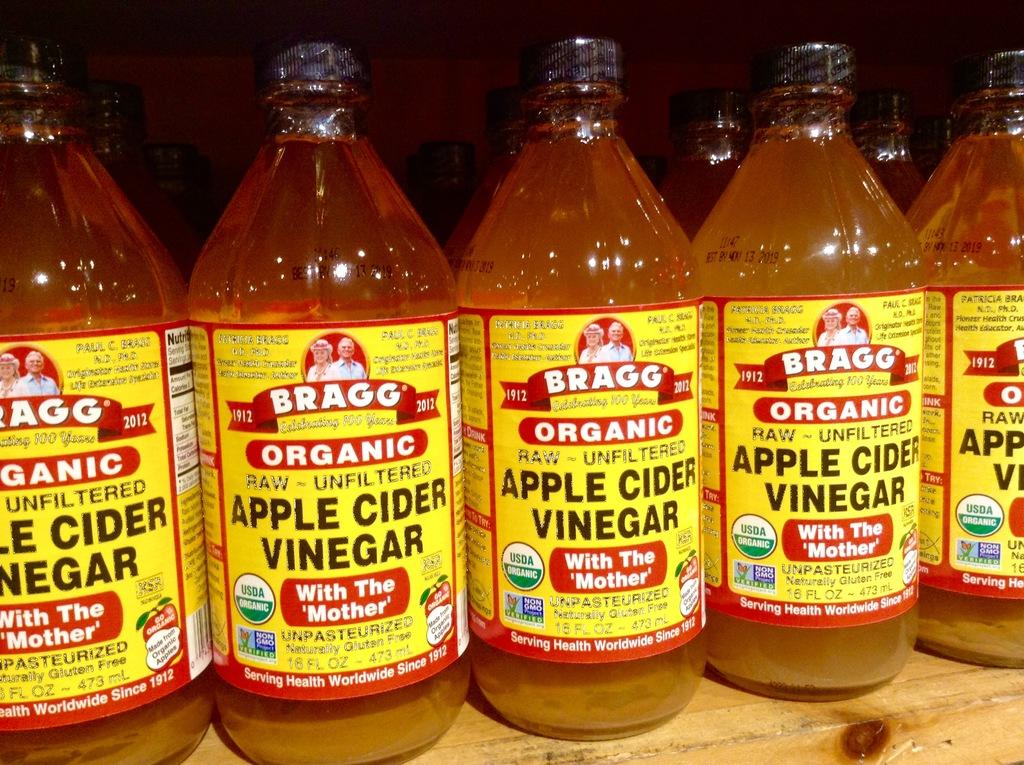What kind of apple cider vinegar is this?
Offer a terse response. Organic. 